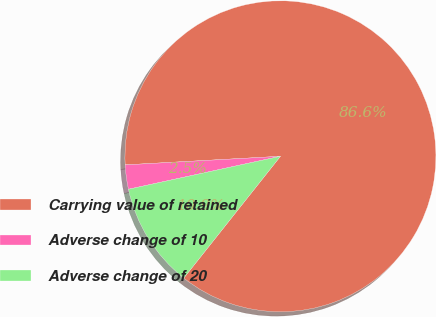Convert chart to OTSL. <chart><loc_0><loc_0><loc_500><loc_500><pie_chart><fcel>Carrying value of retained<fcel>Adverse change of 10<fcel>Adverse change of 20<nl><fcel>86.56%<fcel>2.52%<fcel>10.92%<nl></chart> 